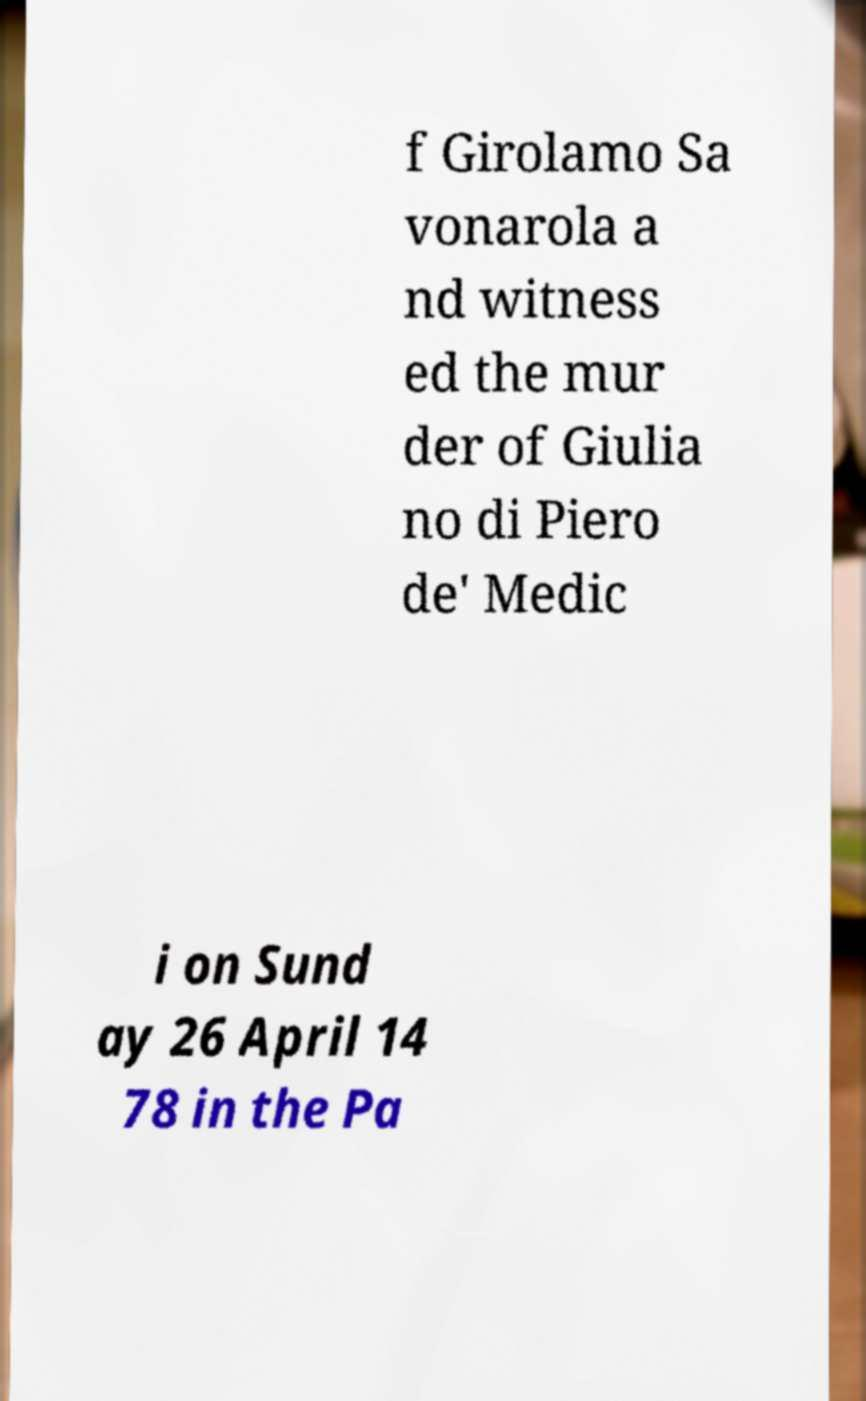Could you assist in decoding the text presented in this image and type it out clearly? f Girolamo Sa vonarola a nd witness ed the mur der of Giulia no di Piero de' Medic i on Sund ay 26 April 14 78 in the Pa 